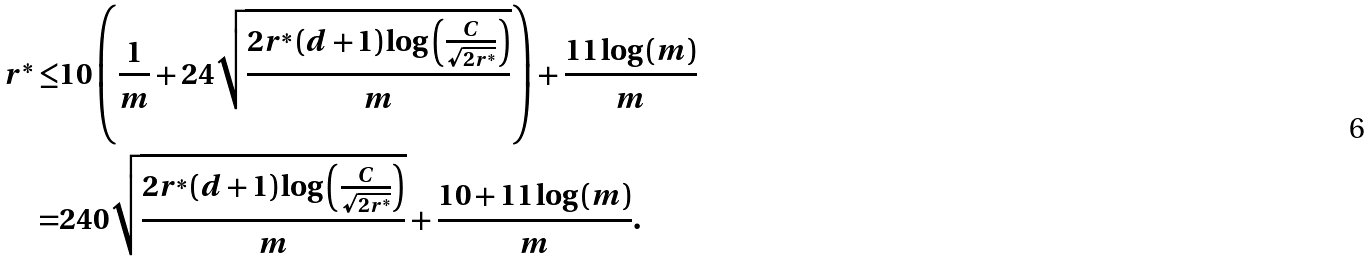Convert formula to latex. <formula><loc_0><loc_0><loc_500><loc_500>r ^ { * } \leq & 1 0 \left ( \frac { 1 } { m } + 2 4 \sqrt { \frac { 2 r ^ { * } \left ( d + 1 \right ) \log \left ( \frac { C } { \sqrt { 2 r ^ { * } } } \right ) } { m } } \right ) + \frac { 1 1 \log \left ( m \right ) } { m } \\ = & 2 4 0 \sqrt { \frac { 2 r ^ { * } \left ( d + 1 \right ) \log \left ( \frac { C } { \sqrt { 2 r ^ { * } } } \right ) } { m } } + \frac { 1 0 + 1 1 \log \left ( m \right ) } { m } .</formula> 